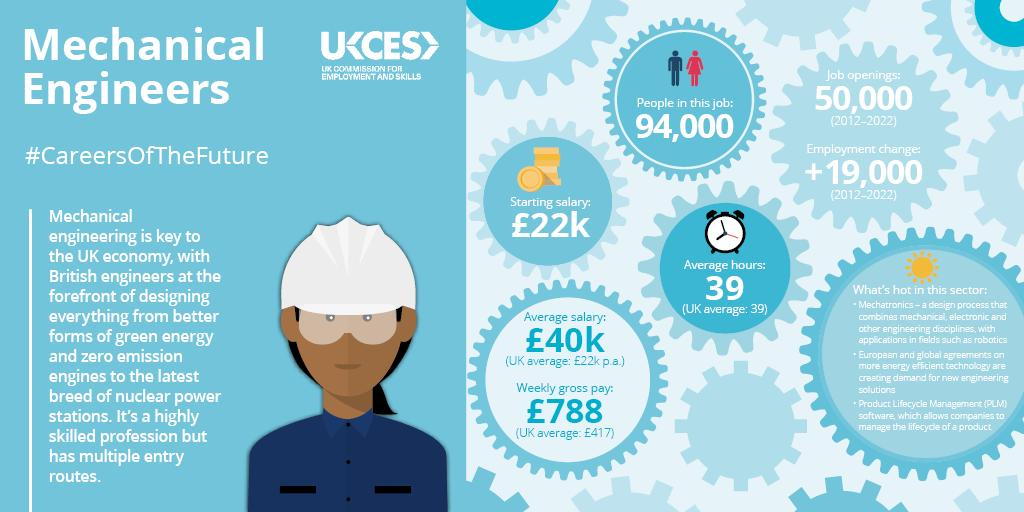Highlight a few significant elements in this photo. The average salary for mechanical engineers in the UK is significantly lower than the average salary for the UK as a whole, with a yearly difference of £18,000. On average, mechanical engineers in the UK earn significantly less than the overall weekly gross pay for the country as a whole, with a difference of £371 per week. 